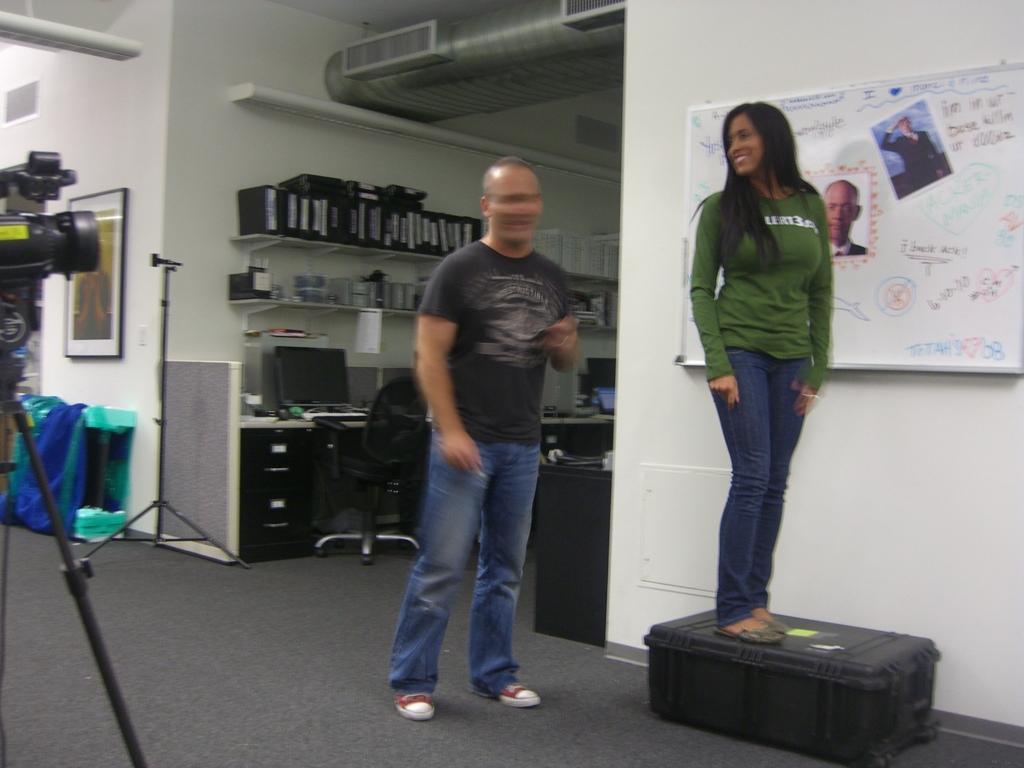Can you describe this image briefly? These two persons standing. On the background we can see wall,frame,chair and things. This is camera with stand. This is floor. We can see white board on the wall. 